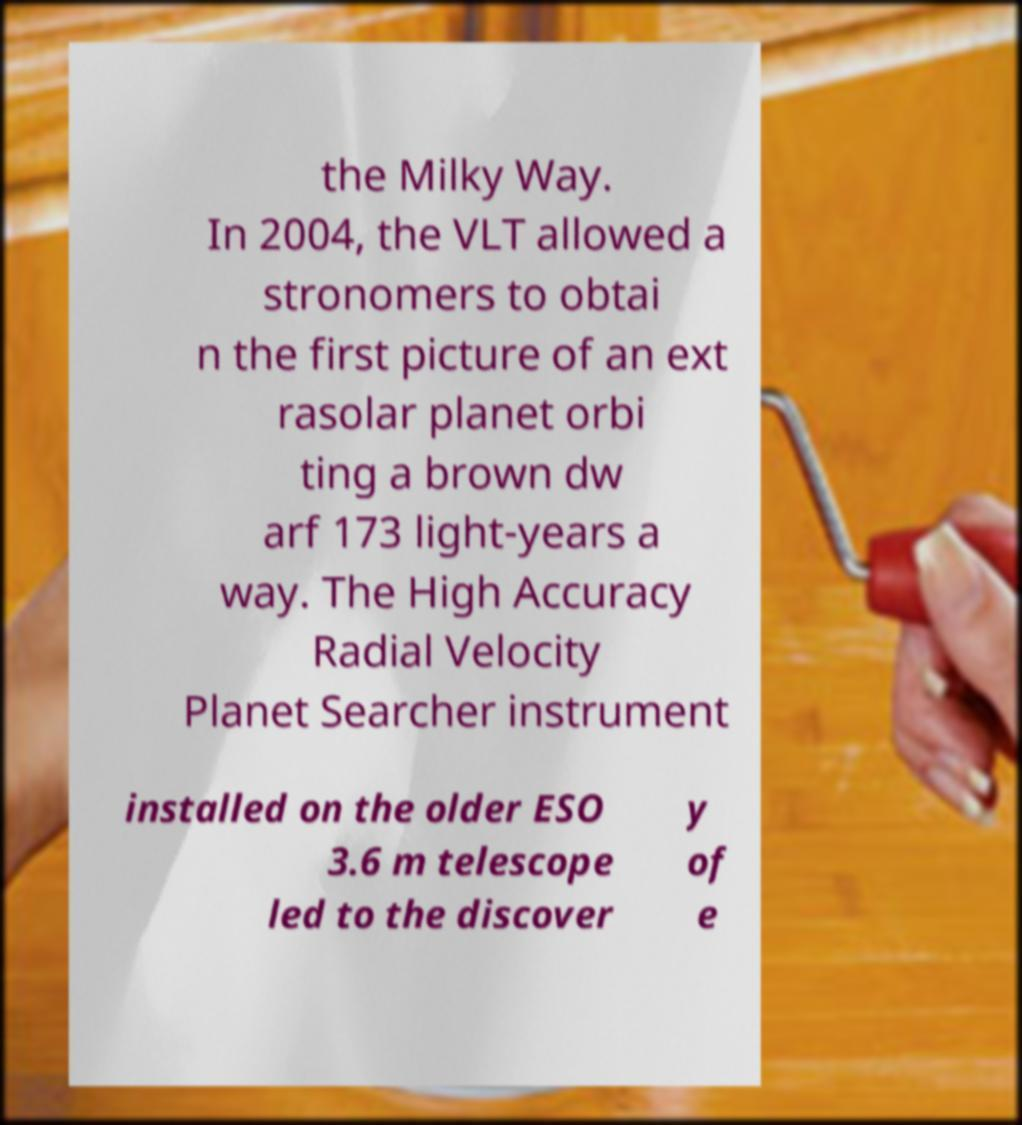Could you assist in decoding the text presented in this image and type it out clearly? the Milky Way. In 2004, the VLT allowed a stronomers to obtai n the first picture of an ext rasolar planet orbi ting a brown dw arf 173 light-years a way. The High Accuracy Radial Velocity Planet Searcher instrument installed on the older ESO 3.6 m telescope led to the discover y of e 